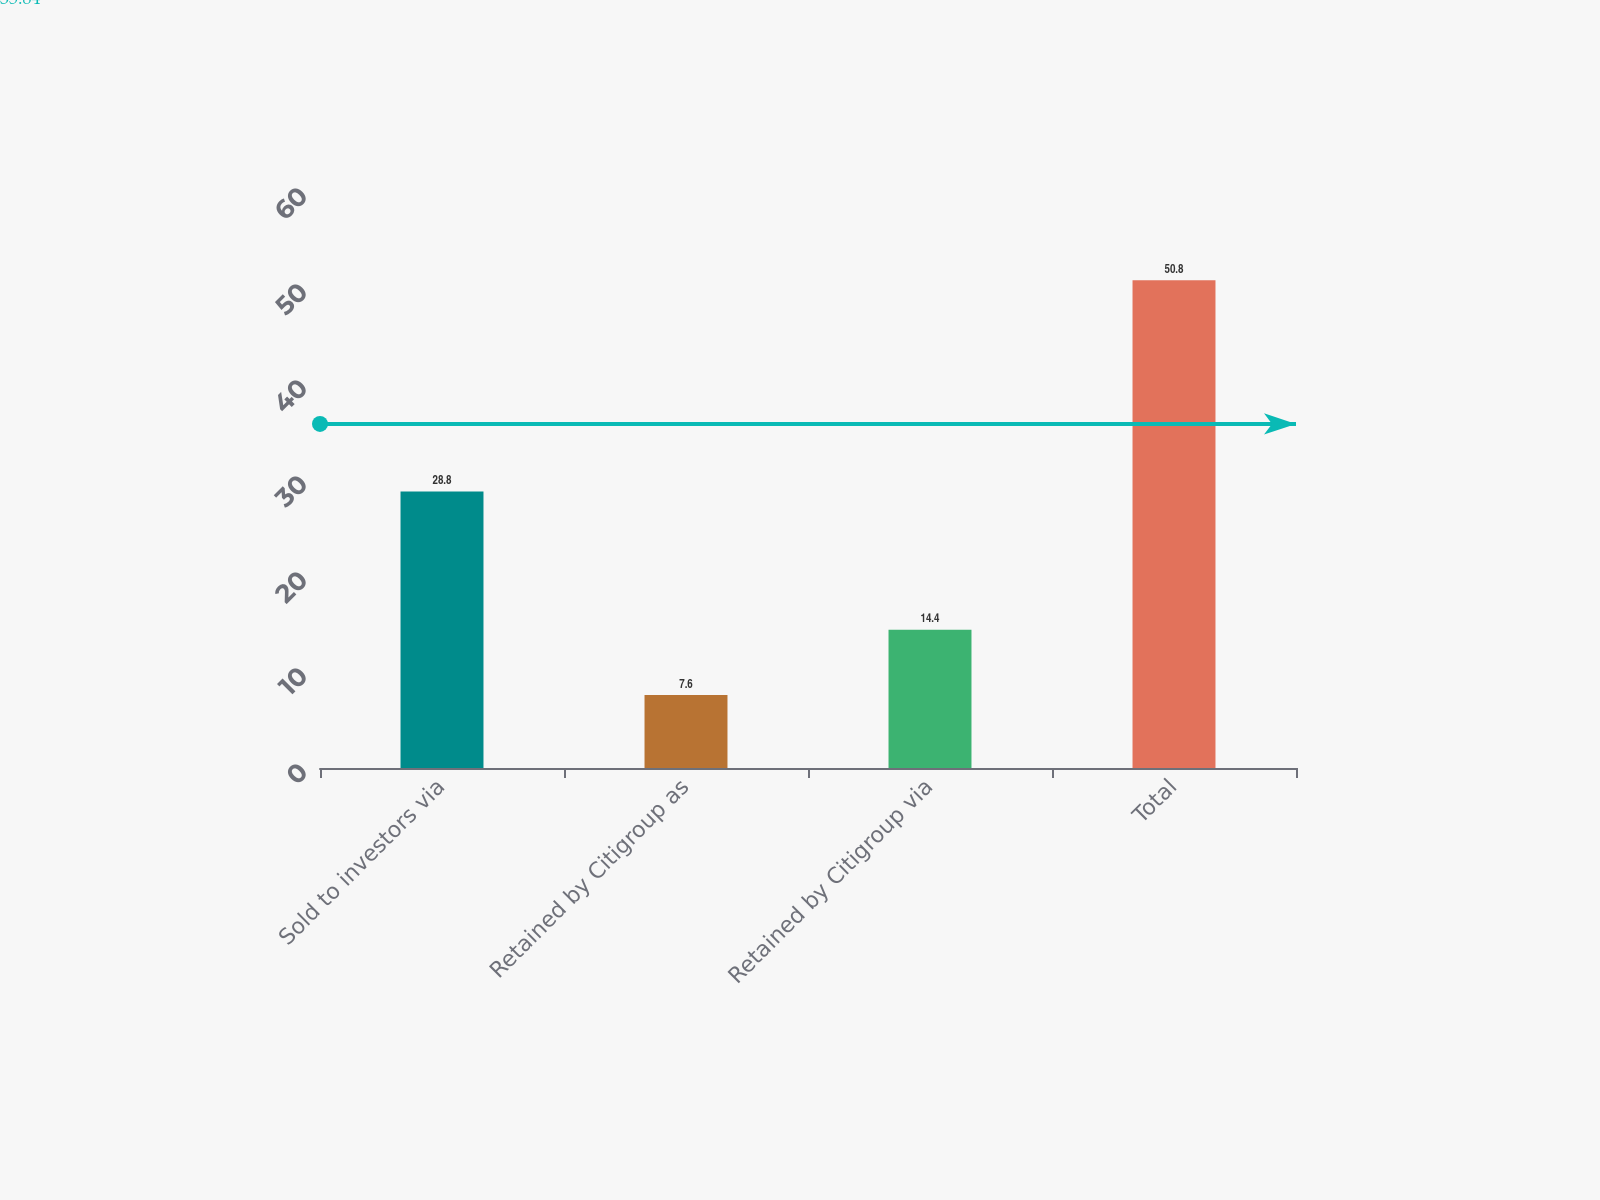Convert chart to OTSL. <chart><loc_0><loc_0><loc_500><loc_500><bar_chart><fcel>Sold to investors via<fcel>Retained by Citigroup as<fcel>Retained by Citigroup via<fcel>Total<nl><fcel>28.8<fcel>7.6<fcel>14.4<fcel>50.8<nl></chart> 